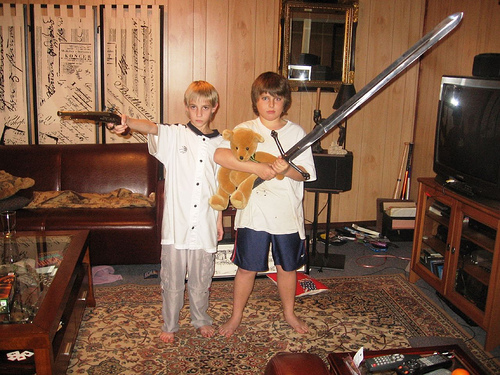How many televisions are in the photo? 1 